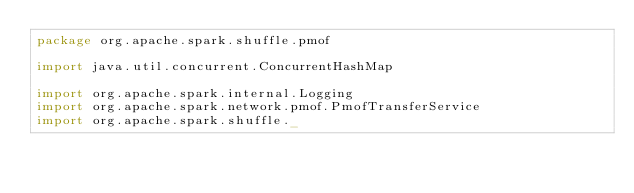<code> <loc_0><loc_0><loc_500><loc_500><_Scala_>package org.apache.spark.shuffle.pmof

import java.util.concurrent.ConcurrentHashMap

import org.apache.spark.internal.Logging
import org.apache.spark.network.pmof.PmofTransferService
import org.apache.spark.shuffle._</code> 